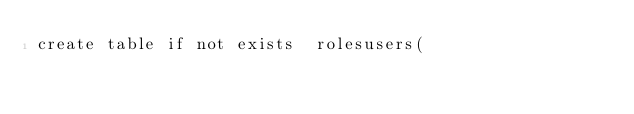Convert code to text. <code><loc_0><loc_0><loc_500><loc_500><_SQL_>create table if not exists  rolesusers(</code> 